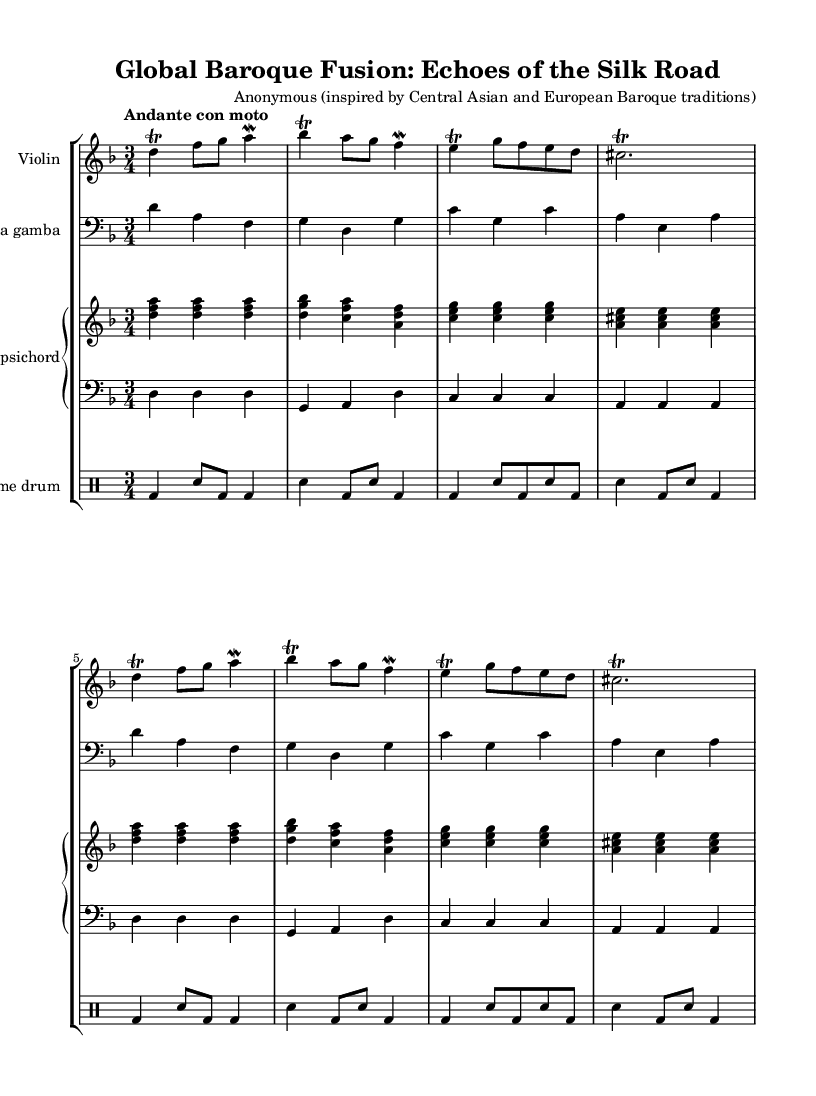What is the key signature of this music? The key signature is D minor, indicated by one flat (B♭). The key is determined by the presence of the sharp signs or flat symbols in the music sheet.
Answer: D minor What is the time signature of this piece? The time signature is 3/4, indicating three beats per measure, with the quarter note getting one beat. This is shown in the upper portion of the sheet music.
Answer: 3/4 What is the tempo marking for this composition? The tempo marking is "Andante con moto," suggesting a moderately slow pace with some movement. This is typically indicated alongside the time signature at the beginning of the piece.
Answer: Andante con moto How many bars does the A section repeat? The A section consists of 8 bars or measures, which is indicated by the repetition of the music every 8 bars in the notation.
Answer: 8 bars What instruments are featured in this piece? The instruments included are violin, viola da gamba, harpsichord, and frame drum, all specified by their respective staves in the score.
Answer: Violin, viola da gamba, harpsichord, frame drum What ornamentation technique is applied to the violin part? The violin part employs trills, indicated by the symbol "tr" above the notes. This shows that the performer should rapidly alternate between the indicated note and the note above it.
Answer: Trills What style of music does this piece represent? The piece represents the Baroque style, characterized by its use of ornamentation, contrapuntal texture, and a focus on expressive melodies. This is evident in the structured rhythmic patterns and harmonic progressions.
Answer: Baroque 